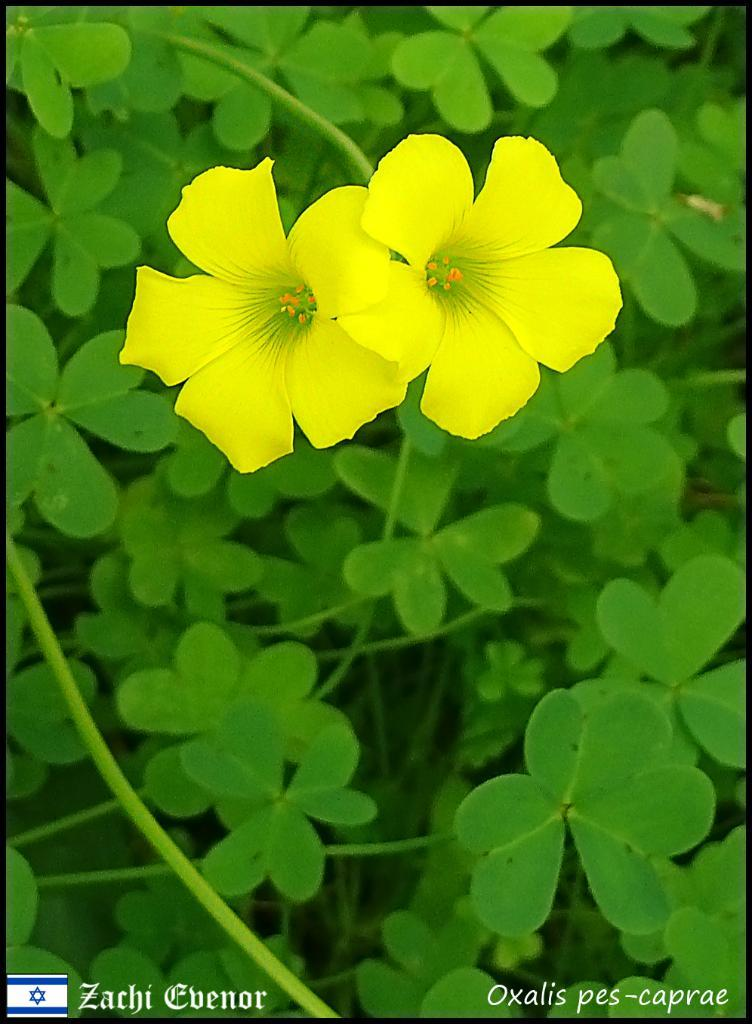How many yellow flowers can be seen in the image? There are two yellow flowers in the image. What else can be seen in the background of the image? There are plants in the background of the image. What type of sign can be seen in the image? There is no sign present in the image; it features two yellow flowers and plants in the background. How many cows are visible in the image? There are no cows present in the image. 